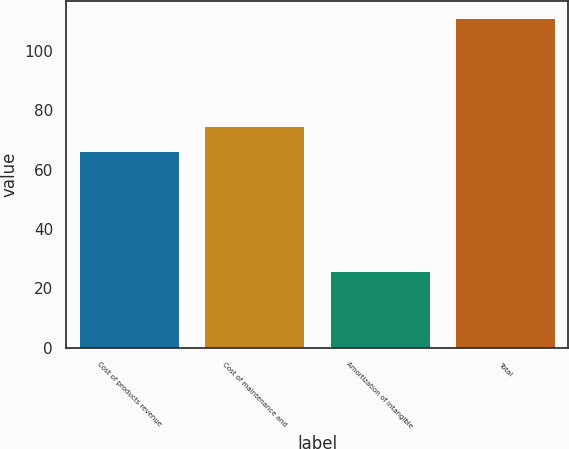<chart> <loc_0><loc_0><loc_500><loc_500><bar_chart><fcel>Cost of products revenue<fcel>Cost of maintenance and<fcel>Amortization of intangible<fcel>Total<nl><fcel>66.3<fcel>74.82<fcel>26<fcel>111.2<nl></chart> 